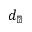Convert formula to latex. <formula><loc_0><loc_0><loc_500><loc_500>d _ { \perp }</formula> 